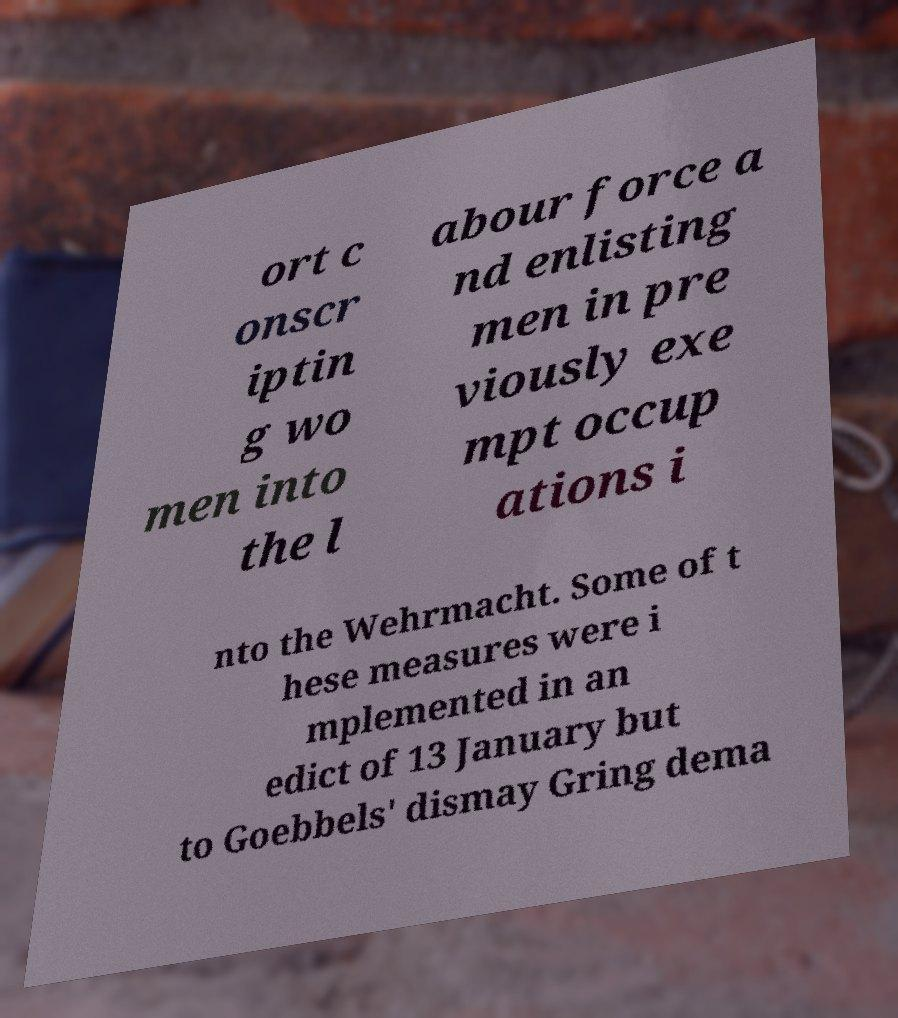Could you assist in decoding the text presented in this image and type it out clearly? ort c onscr iptin g wo men into the l abour force a nd enlisting men in pre viously exe mpt occup ations i nto the Wehrmacht. Some of t hese measures were i mplemented in an edict of 13 January but to Goebbels' dismay Gring dema 